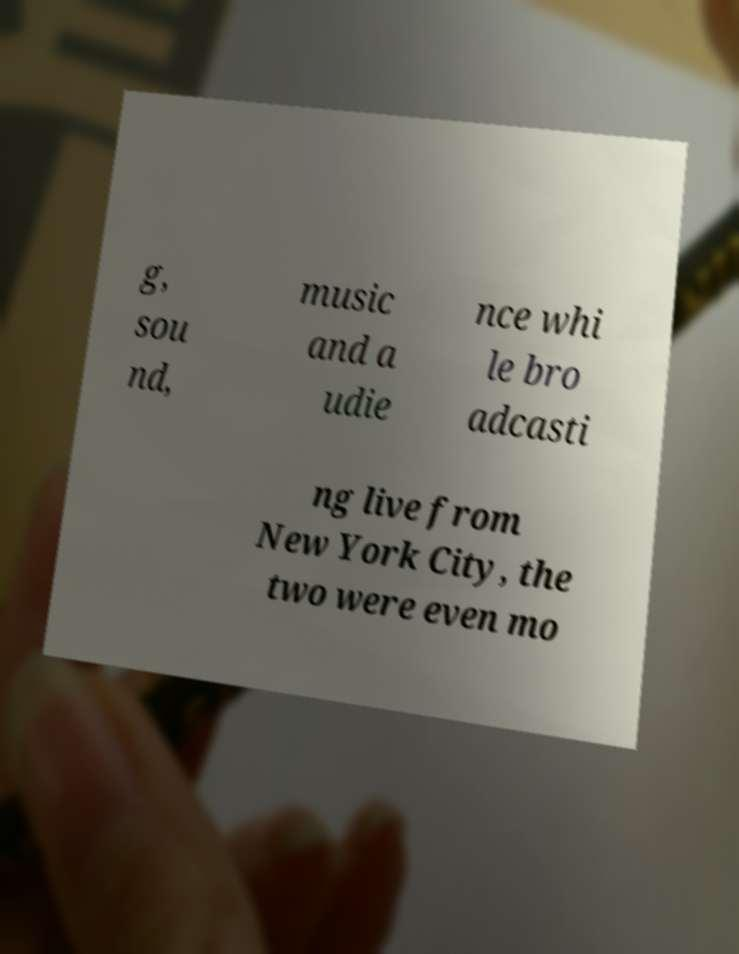There's text embedded in this image that I need extracted. Can you transcribe it verbatim? g, sou nd, music and a udie nce whi le bro adcasti ng live from New York City, the two were even mo 